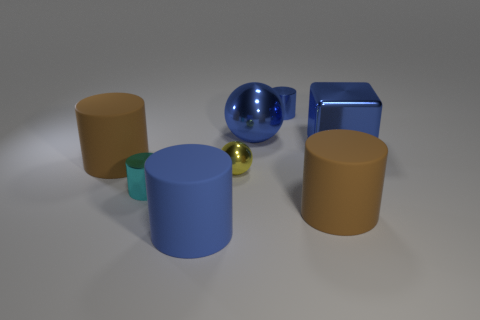Subtract all cyan cylinders. How many cylinders are left? 4 Subtract all small blue cylinders. How many cylinders are left? 4 Subtract all purple cylinders. Subtract all green balls. How many cylinders are left? 5 Add 1 small spheres. How many objects exist? 9 Subtract all cubes. How many objects are left? 7 Subtract 0 cyan blocks. How many objects are left? 8 Subtract all cyan shiny things. Subtract all cylinders. How many objects are left? 2 Add 5 big brown cylinders. How many big brown cylinders are left? 7 Add 7 tiny cyan shiny cylinders. How many tiny cyan shiny cylinders exist? 8 